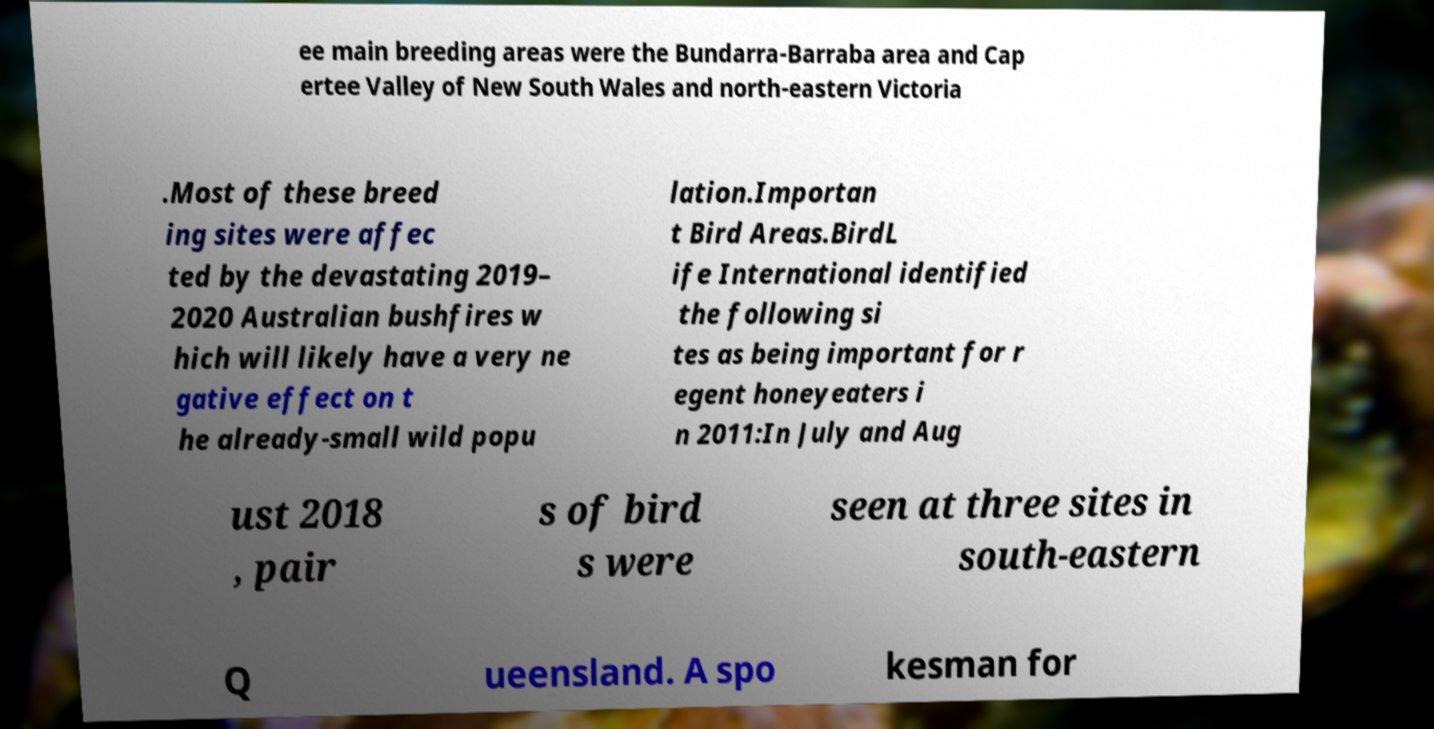Can you read and provide the text displayed in the image?This photo seems to have some interesting text. Can you extract and type it out for me? ee main breeding areas were the Bundarra-Barraba area and Cap ertee Valley of New South Wales and north-eastern Victoria .Most of these breed ing sites were affec ted by the devastating 2019– 2020 Australian bushfires w hich will likely have a very ne gative effect on t he already-small wild popu lation.Importan t Bird Areas.BirdL ife International identified the following si tes as being important for r egent honeyeaters i n 2011:In July and Aug ust 2018 , pair s of bird s were seen at three sites in south-eastern Q ueensland. A spo kesman for 